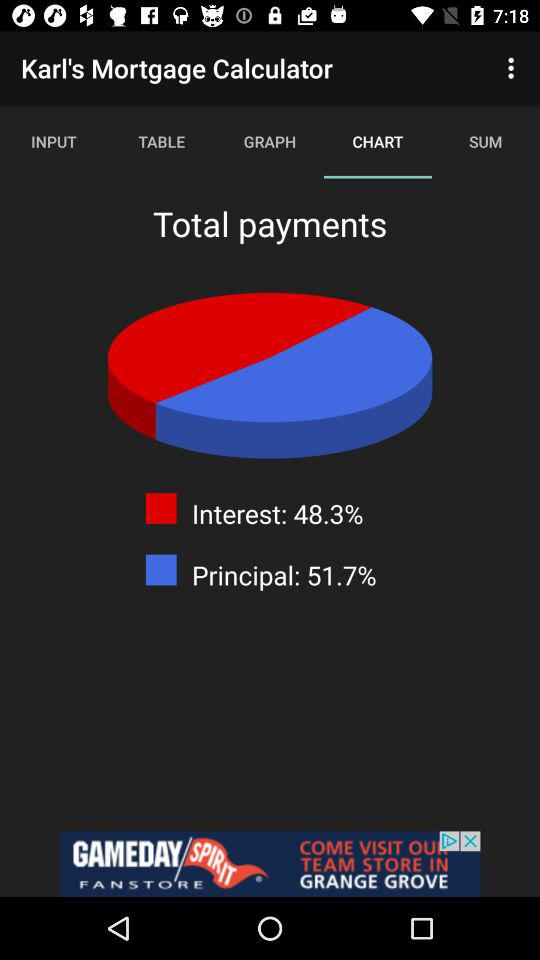What is the interest percentage? The interest percentage is 48.3. 